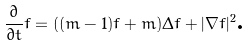Convert formula to latex. <formula><loc_0><loc_0><loc_500><loc_500>\frac { \partial } { \partial t } f = ( ( m - 1 ) f + m ) \Delta f + | \nabla f | ^ { 2 } \text {.}</formula> 